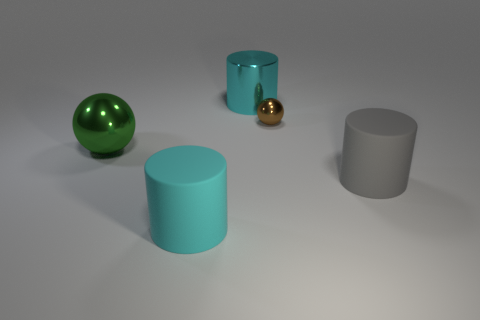Does the large metallic thing behind the brown sphere have the same shape as the large thing right of the large cyan metallic cylinder? Yes, the large metallic object behind the brown sphere shares the same cylindrical shape as the object to the right of the large cyan cylinder. They seem to be part of a set of geometrically shaped objects, each displaying a different material finish and color for visual contrast. 